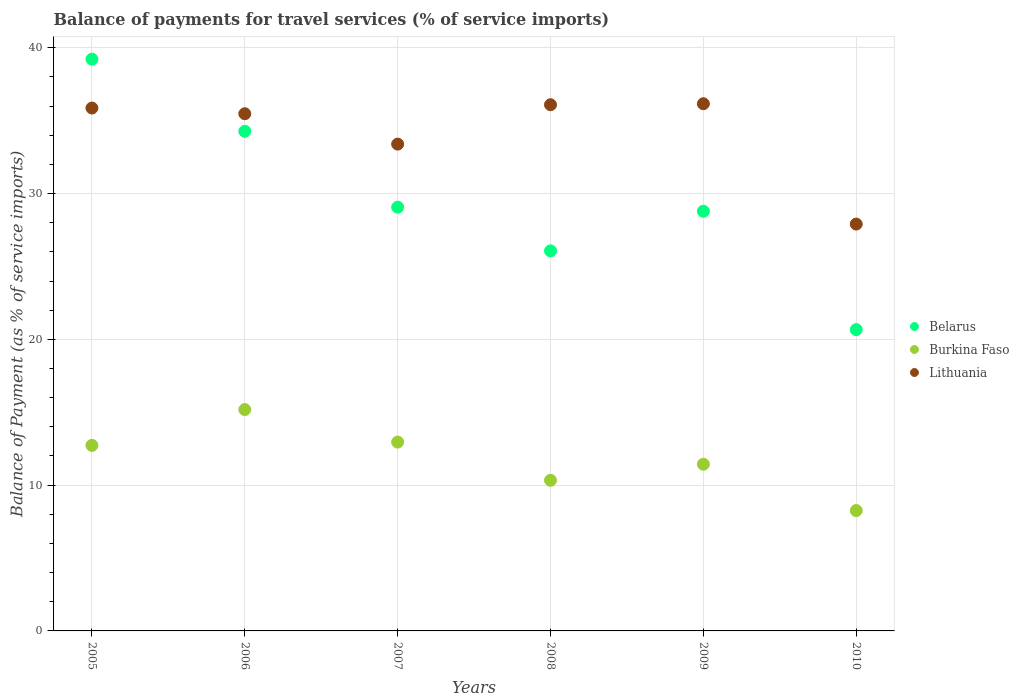How many different coloured dotlines are there?
Provide a succinct answer. 3. What is the balance of payments for travel services in Belarus in 2010?
Offer a very short reply. 20.67. Across all years, what is the maximum balance of payments for travel services in Belarus?
Your answer should be compact. 39.22. Across all years, what is the minimum balance of payments for travel services in Burkina Faso?
Offer a terse response. 8.26. In which year was the balance of payments for travel services in Lithuania minimum?
Offer a very short reply. 2010. What is the total balance of payments for travel services in Belarus in the graph?
Make the answer very short. 178.08. What is the difference between the balance of payments for travel services in Burkina Faso in 2005 and that in 2009?
Give a very brief answer. 1.29. What is the difference between the balance of payments for travel services in Lithuania in 2007 and the balance of payments for travel services in Burkina Faso in 2010?
Your response must be concise. 25.14. What is the average balance of payments for travel services in Burkina Faso per year?
Provide a succinct answer. 11.81. In the year 2008, what is the difference between the balance of payments for travel services in Lithuania and balance of payments for travel services in Burkina Faso?
Give a very brief answer. 25.76. What is the ratio of the balance of payments for travel services in Belarus in 2006 to that in 2010?
Keep it short and to the point. 1.66. What is the difference between the highest and the second highest balance of payments for travel services in Burkina Faso?
Ensure brevity in your answer.  2.23. What is the difference between the highest and the lowest balance of payments for travel services in Lithuania?
Make the answer very short. 8.25. In how many years, is the balance of payments for travel services in Burkina Faso greater than the average balance of payments for travel services in Burkina Faso taken over all years?
Ensure brevity in your answer.  3. Is it the case that in every year, the sum of the balance of payments for travel services in Belarus and balance of payments for travel services in Lithuania  is greater than the balance of payments for travel services in Burkina Faso?
Make the answer very short. Yes. Is the balance of payments for travel services in Belarus strictly greater than the balance of payments for travel services in Burkina Faso over the years?
Your response must be concise. Yes. Are the values on the major ticks of Y-axis written in scientific E-notation?
Your response must be concise. No. Does the graph contain grids?
Provide a short and direct response. Yes. What is the title of the graph?
Provide a short and direct response. Balance of payments for travel services (% of service imports). Does "Cambodia" appear as one of the legend labels in the graph?
Keep it short and to the point. No. What is the label or title of the Y-axis?
Give a very brief answer. Balance of Payment (as % of service imports). What is the Balance of Payment (as % of service imports) in Belarus in 2005?
Provide a short and direct response. 39.22. What is the Balance of Payment (as % of service imports) of Burkina Faso in 2005?
Provide a succinct answer. 12.73. What is the Balance of Payment (as % of service imports) of Lithuania in 2005?
Your answer should be very brief. 35.87. What is the Balance of Payment (as % of service imports) in Belarus in 2006?
Give a very brief answer. 34.27. What is the Balance of Payment (as % of service imports) of Burkina Faso in 2006?
Your answer should be very brief. 15.18. What is the Balance of Payment (as % of service imports) of Lithuania in 2006?
Your answer should be very brief. 35.48. What is the Balance of Payment (as % of service imports) of Belarus in 2007?
Make the answer very short. 29.07. What is the Balance of Payment (as % of service imports) of Burkina Faso in 2007?
Offer a very short reply. 12.95. What is the Balance of Payment (as % of service imports) of Lithuania in 2007?
Give a very brief answer. 33.39. What is the Balance of Payment (as % of service imports) of Belarus in 2008?
Keep it short and to the point. 26.07. What is the Balance of Payment (as % of service imports) in Burkina Faso in 2008?
Provide a short and direct response. 10.33. What is the Balance of Payment (as % of service imports) in Lithuania in 2008?
Offer a very short reply. 36.09. What is the Balance of Payment (as % of service imports) of Belarus in 2009?
Offer a very short reply. 28.79. What is the Balance of Payment (as % of service imports) of Burkina Faso in 2009?
Keep it short and to the point. 11.43. What is the Balance of Payment (as % of service imports) in Lithuania in 2009?
Offer a terse response. 36.16. What is the Balance of Payment (as % of service imports) of Belarus in 2010?
Give a very brief answer. 20.67. What is the Balance of Payment (as % of service imports) of Burkina Faso in 2010?
Offer a terse response. 8.26. What is the Balance of Payment (as % of service imports) in Lithuania in 2010?
Offer a very short reply. 27.91. Across all years, what is the maximum Balance of Payment (as % of service imports) in Belarus?
Ensure brevity in your answer.  39.22. Across all years, what is the maximum Balance of Payment (as % of service imports) in Burkina Faso?
Provide a succinct answer. 15.18. Across all years, what is the maximum Balance of Payment (as % of service imports) of Lithuania?
Your response must be concise. 36.16. Across all years, what is the minimum Balance of Payment (as % of service imports) in Belarus?
Offer a terse response. 20.67. Across all years, what is the minimum Balance of Payment (as % of service imports) in Burkina Faso?
Ensure brevity in your answer.  8.26. Across all years, what is the minimum Balance of Payment (as % of service imports) of Lithuania?
Offer a terse response. 27.91. What is the total Balance of Payment (as % of service imports) of Belarus in the graph?
Keep it short and to the point. 178.08. What is the total Balance of Payment (as % of service imports) of Burkina Faso in the graph?
Give a very brief answer. 70.89. What is the total Balance of Payment (as % of service imports) of Lithuania in the graph?
Offer a very short reply. 204.89. What is the difference between the Balance of Payment (as % of service imports) in Belarus in 2005 and that in 2006?
Ensure brevity in your answer.  4.95. What is the difference between the Balance of Payment (as % of service imports) in Burkina Faso in 2005 and that in 2006?
Your answer should be compact. -2.46. What is the difference between the Balance of Payment (as % of service imports) in Lithuania in 2005 and that in 2006?
Provide a short and direct response. 0.39. What is the difference between the Balance of Payment (as % of service imports) in Belarus in 2005 and that in 2007?
Your answer should be compact. 10.15. What is the difference between the Balance of Payment (as % of service imports) in Burkina Faso in 2005 and that in 2007?
Offer a terse response. -0.23. What is the difference between the Balance of Payment (as % of service imports) of Lithuania in 2005 and that in 2007?
Offer a terse response. 2.47. What is the difference between the Balance of Payment (as % of service imports) of Belarus in 2005 and that in 2008?
Your response must be concise. 13.15. What is the difference between the Balance of Payment (as % of service imports) in Burkina Faso in 2005 and that in 2008?
Your answer should be very brief. 2.39. What is the difference between the Balance of Payment (as % of service imports) in Lithuania in 2005 and that in 2008?
Give a very brief answer. -0.23. What is the difference between the Balance of Payment (as % of service imports) in Belarus in 2005 and that in 2009?
Make the answer very short. 10.43. What is the difference between the Balance of Payment (as % of service imports) in Burkina Faso in 2005 and that in 2009?
Your response must be concise. 1.29. What is the difference between the Balance of Payment (as % of service imports) in Lithuania in 2005 and that in 2009?
Your response must be concise. -0.29. What is the difference between the Balance of Payment (as % of service imports) in Belarus in 2005 and that in 2010?
Offer a terse response. 18.55. What is the difference between the Balance of Payment (as % of service imports) of Burkina Faso in 2005 and that in 2010?
Ensure brevity in your answer.  4.47. What is the difference between the Balance of Payment (as % of service imports) in Lithuania in 2005 and that in 2010?
Your answer should be very brief. 7.96. What is the difference between the Balance of Payment (as % of service imports) of Belarus in 2006 and that in 2007?
Your answer should be very brief. 5.2. What is the difference between the Balance of Payment (as % of service imports) of Burkina Faso in 2006 and that in 2007?
Ensure brevity in your answer.  2.23. What is the difference between the Balance of Payment (as % of service imports) of Lithuania in 2006 and that in 2007?
Your response must be concise. 2.08. What is the difference between the Balance of Payment (as % of service imports) of Belarus in 2006 and that in 2008?
Make the answer very short. 8.2. What is the difference between the Balance of Payment (as % of service imports) in Burkina Faso in 2006 and that in 2008?
Ensure brevity in your answer.  4.85. What is the difference between the Balance of Payment (as % of service imports) of Lithuania in 2006 and that in 2008?
Give a very brief answer. -0.62. What is the difference between the Balance of Payment (as % of service imports) of Belarus in 2006 and that in 2009?
Keep it short and to the point. 5.48. What is the difference between the Balance of Payment (as % of service imports) of Burkina Faso in 2006 and that in 2009?
Offer a terse response. 3.75. What is the difference between the Balance of Payment (as % of service imports) in Lithuania in 2006 and that in 2009?
Give a very brief answer. -0.69. What is the difference between the Balance of Payment (as % of service imports) of Belarus in 2006 and that in 2010?
Keep it short and to the point. 13.6. What is the difference between the Balance of Payment (as % of service imports) in Burkina Faso in 2006 and that in 2010?
Offer a terse response. 6.93. What is the difference between the Balance of Payment (as % of service imports) in Lithuania in 2006 and that in 2010?
Provide a succinct answer. 7.57. What is the difference between the Balance of Payment (as % of service imports) in Belarus in 2007 and that in 2008?
Offer a terse response. 3. What is the difference between the Balance of Payment (as % of service imports) of Burkina Faso in 2007 and that in 2008?
Ensure brevity in your answer.  2.62. What is the difference between the Balance of Payment (as % of service imports) in Lithuania in 2007 and that in 2008?
Your answer should be compact. -2.7. What is the difference between the Balance of Payment (as % of service imports) in Belarus in 2007 and that in 2009?
Your answer should be very brief. 0.28. What is the difference between the Balance of Payment (as % of service imports) in Burkina Faso in 2007 and that in 2009?
Offer a terse response. 1.52. What is the difference between the Balance of Payment (as % of service imports) in Lithuania in 2007 and that in 2009?
Your answer should be very brief. -2.77. What is the difference between the Balance of Payment (as % of service imports) in Belarus in 2007 and that in 2010?
Provide a succinct answer. 8.4. What is the difference between the Balance of Payment (as % of service imports) in Burkina Faso in 2007 and that in 2010?
Offer a very short reply. 4.7. What is the difference between the Balance of Payment (as % of service imports) in Lithuania in 2007 and that in 2010?
Offer a terse response. 5.48. What is the difference between the Balance of Payment (as % of service imports) of Belarus in 2008 and that in 2009?
Give a very brief answer. -2.72. What is the difference between the Balance of Payment (as % of service imports) of Burkina Faso in 2008 and that in 2009?
Offer a very short reply. -1.1. What is the difference between the Balance of Payment (as % of service imports) in Lithuania in 2008 and that in 2009?
Your response must be concise. -0.07. What is the difference between the Balance of Payment (as % of service imports) of Belarus in 2008 and that in 2010?
Your response must be concise. 5.4. What is the difference between the Balance of Payment (as % of service imports) of Burkina Faso in 2008 and that in 2010?
Your answer should be very brief. 2.08. What is the difference between the Balance of Payment (as % of service imports) of Lithuania in 2008 and that in 2010?
Your answer should be compact. 8.19. What is the difference between the Balance of Payment (as % of service imports) of Belarus in 2009 and that in 2010?
Keep it short and to the point. 8.12. What is the difference between the Balance of Payment (as % of service imports) in Burkina Faso in 2009 and that in 2010?
Provide a succinct answer. 3.18. What is the difference between the Balance of Payment (as % of service imports) in Lithuania in 2009 and that in 2010?
Provide a short and direct response. 8.25. What is the difference between the Balance of Payment (as % of service imports) of Belarus in 2005 and the Balance of Payment (as % of service imports) of Burkina Faso in 2006?
Make the answer very short. 24.04. What is the difference between the Balance of Payment (as % of service imports) in Belarus in 2005 and the Balance of Payment (as % of service imports) in Lithuania in 2006?
Provide a succinct answer. 3.74. What is the difference between the Balance of Payment (as % of service imports) of Burkina Faso in 2005 and the Balance of Payment (as % of service imports) of Lithuania in 2006?
Your answer should be very brief. -22.75. What is the difference between the Balance of Payment (as % of service imports) of Belarus in 2005 and the Balance of Payment (as % of service imports) of Burkina Faso in 2007?
Keep it short and to the point. 26.27. What is the difference between the Balance of Payment (as % of service imports) of Belarus in 2005 and the Balance of Payment (as % of service imports) of Lithuania in 2007?
Provide a succinct answer. 5.83. What is the difference between the Balance of Payment (as % of service imports) of Burkina Faso in 2005 and the Balance of Payment (as % of service imports) of Lithuania in 2007?
Provide a succinct answer. -20.67. What is the difference between the Balance of Payment (as % of service imports) in Belarus in 2005 and the Balance of Payment (as % of service imports) in Burkina Faso in 2008?
Give a very brief answer. 28.89. What is the difference between the Balance of Payment (as % of service imports) of Belarus in 2005 and the Balance of Payment (as % of service imports) of Lithuania in 2008?
Ensure brevity in your answer.  3.13. What is the difference between the Balance of Payment (as % of service imports) in Burkina Faso in 2005 and the Balance of Payment (as % of service imports) in Lithuania in 2008?
Your response must be concise. -23.37. What is the difference between the Balance of Payment (as % of service imports) in Belarus in 2005 and the Balance of Payment (as % of service imports) in Burkina Faso in 2009?
Ensure brevity in your answer.  27.79. What is the difference between the Balance of Payment (as % of service imports) of Belarus in 2005 and the Balance of Payment (as % of service imports) of Lithuania in 2009?
Make the answer very short. 3.06. What is the difference between the Balance of Payment (as % of service imports) in Burkina Faso in 2005 and the Balance of Payment (as % of service imports) in Lithuania in 2009?
Your response must be concise. -23.44. What is the difference between the Balance of Payment (as % of service imports) in Belarus in 2005 and the Balance of Payment (as % of service imports) in Burkina Faso in 2010?
Provide a short and direct response. 30.96. What is the difference between the Balance of Payment (as % of service imports) in Belarus in 2005 and the Balance of Payment (as % of service imports) in Lithuania in 2010?
Ensure brevity in your answer.  11.31. What is the difference between the Balance of Payment (as % of service imports) in Burkina Faso in 2005 and the Balance of Payment (as % of service imports) in Lithuania in 2010?
Keep it short and to the point. -15.18. What is the difference between the Balance of Payment (as % of service imports) in Belarus in 2006 and the Balance of Payment (as % of service imports) in Burkina Faso in 2007?
Your answer should be very brief. 21.32. What is the difference between the Balance of Payment (as % of service imports) of Belarus in 2006 and the Balance of Payment (as % of service imports) of Lithuania in 2007?
Keep it short and to the point. 0.88. What is the difference between the Balance of Payment (as % of service imports) of Burkina Faso in 2006 and the Balance of Payment (as % of service imports) of Lithuania in 2007?
Your answer should be very brief. -18.21. What is the difference between the Balance of Payment (as % of service imports) of Belarus in 2006 and the Balance of Payment (as % of service imports) of Burkina Faso in 2008?
Ensure brevity in your answer.  23.94. What is the difference between the Balance of Payment (as % of service imports) in Belarus in 2006 and the Balance of Payment (as % of service imports) in Lithuania in 2008?
Make the answer very short. -1.82. What is the difference between the Balance of Payment (as % of service imports) of Burkina Faso in 2006 and the Balance of Payment (as % of service imports) of Lithuania in 2008?
Your response must be concise. -20.91. What is the difference between the Balance of Payment (as % of service imports) in Belarus in 2006 and the Balance of Payment (as % of service imports) in Burkina Faso in 2009?
Your answer should be compact. 22.84. What is the difference between the Balance of Payment (as % of service imports) of Belarus in 2006 and the Balance of Payment (as % of service imports) of Lithuania in 2009?
Your response must be concise. -1.89. What is the difference between the Balance of Payment (as % of service imports) of Burkina Faso in 2006 and the Balance of Payment (as % of service imports) of Lithuania in 2009?
Your answer should be very brief. -20.98. What is the difference between the Balance of Payment (as % of service imports) of Belarus in 2006 and the Balance of Payment (as % of service imports) of Burkina Faso in 2010?
Give a very brief answer. 26.01. What is the difference between the Balance of Payment (as % of service imports) in Belarus in 2006 and the Balance of Payment (as % of service imports) in Lithuania in 2010?
Give a very brief answer. 6.36. What is the difference between the Balance of Payment (as % of service imports) in Burkina Faso in 2006 and the Balance of Payment (as % of service imports) in Lithuania in 2010?
Provide a succinct answer. -12.72. What is the difference between the Balance of Payment (as % of service imports) in Belarus in 2007 and the Balance of Payment (as % of service imports) in Burkina Faso in 2008?
Your answer should be compact. 18.73. What is the difference between the Balance of Payment (as % of service imports) of Belarus in 2007 and the Balance of Payment (as % of service imports) of Lithuania in 2008?
Offer a terse response. -7.03. What is the difference between the Balance of Payment (as % of service imports) of Burkina Faso in 2007 and the Balance of Payment (as % of service imports) of Lithuania in 2008?
Provide a succinct answer. -23.14. What is the difference between the Balance of Payment (as % of service imports) of Belarus in 2007 and the Balance of Payment (as % of service imports) of Burkina Faso in 2009?
Keep it short and to the point. 17.63. What is the difference between the Balance of Payment (as % of service imports) in Belarus in 2007 and the Balance of Payment (as % of service imports) in Lithuania in 2009?
Keep it short and to the point. -7.09. What is the difference between the Balance of Payment (as % of service imports) of Burkina Faso in 2007 and the Balance of Payment (as % of service imports) of Lithuania in 2009?
Offer a very short reply. -23.21. What is the difference between the Balance of Payment (as % of service imports) of Belarus in 2007 and the Balance of Payment (as % of service imports) of Burkina Faso in 2010?
Provide a succinct answer. 20.81. What is the difference between the Balance of Payment (as % of service imports) in Belarus in 2007 and the Balance of Payment (as % of service imports) in Lithuania in 2010?
Your answer should be compact. 1.16. What is the difference between the Balance of Payment (as % of service imports) of Burkina Faso in 2007 and the Balance of Payment (as % of service imports) of Lithuania in 2010?
Your answer should be very brief. -14.95. What is the difference between the Balance of Payment (as % of service imports) in Belarus in 2008 and the Balance of Payment (as % of service imports) in Burkina Faso in 2009?
Provide a short and direct response. 14.64. What is the difference between the Balance of Payment (as % of service imports) in Belarus in 2008 and the Balance of Payment (as % of service imports) in Lithuania in 2009?
Your answer should be compact. -10.09. What is the difference between the Balance of Payment (as % of service imports) in Burkina Faso in 2008 and the Balance of Payment (as % of service imports) in Lithuania in 2009?
Your response must be concise. -25.83. What is the difference between the Balance of Payment (as % of service imports) of Belarus in 2008 and the Balance of Payment (as % of service imports) of Burkina Faso in 2010?
Provide a succinct answer. 17.81. What is the difference between the Balance of Payment (as % of service imports) of Belarus in 2008 and the Balance of Payment (as % of service imports) of Lithuania in 2010?
Give a very brief answer. -1.84. What is the difference between the Balance of Payment (as % of service imports) in Burkina Faso in 2008 and the Balance of Payment (as % of service imports) in Lithuania in 2010?
Make the answer very short. -17.57. What is the difference between the Balance of Payment (as % of service imports) of Belarus in 2009 and the Balance of Payment (as % of service imports) of Burkina Faso in 2010?
Your answer should be very brief. 20.53. What is the difference between the Balance of Payment (as % of service imports) in Belarus in 2009 and the Balance of Payment (as % of service imports) in Lithuania in 2010?
Ensure brevity in your answer.  0.88. What is the difference between the Balance of Payment (as % of service imports) in Burkina Faso in 2009 and the Balance of Payment (as % of service imports) in Lithuania in 2010?
Provide a short and direct response. -16.47. What is the average Balance of Payment (as % of service imports) of Belarus per year?
Make the answer very short. 29.68. What is the average Balance of Payment (as % of service imports) of Burkina Faso per year?
Offer a very short reply. 11.81. What is the average Balance of Payment (as % of service imports) of Lithuania per year?
Make the answer very short. 34.15. In the year 2005, what is the difference between the Balance of Payment (as % of service imports) in Belarus and Balance of Payment (as % of service imports) in Burkina Faso?
Provide a short and direct response. 26.49. In the year 2005, what is the difference between the Balance of Payment (as % of service imports) in Belarus and Balance of Payment (as % of service imports) in Lithuania?
Offer a terse response. 3.35. In the year 2005, what is the difference between the Balance of Payment (as % of service imports) in Burkina Faso and Balance of Payment (as % of service imports) in Lithuania?
Keep it short and to the point. -23.14. In the year 2006, what is the difference between the Balance of Payment (as % of service imports) in Belarus and Balance of Payment (as % of service imports) in Burkina Faso?
Offer a terse response. 19.09. In the year 2006, what is the difference between the Balance of Payment (as % of service imports) of Belarus and Balance of Payment (as % of service imports) of Lithuania?
Make the answer very short. -1.21. In the year 2006, what is the difference between the Balance of Payment (as % of service imports) in Burkina Faso and Balance of Payment (as % of service imports) in Lithuania?
Give a very brief answer. -20.29. In the year 2007, what is the difference between the Balance of Payment (as % of service imports) of Belarus and Balance of Payment (as % of service imports) of Burkina Faso?
Offer a very short reply. 16.11. In the year 2007, what is the difference between the Balance of Payment (as % of service imports) in Belarus and Balance of Payment (as % of service imports) in Lithuania?
Offer a very short reply. -4.32. In the year 2007, what is the difference between the Balance of Payment (as % of service imports) in Burkina Faso and Balance of Payment (as % of service imports) in Lithuania?
Your answer should be very brief. -20.44. In the year 2008, what is the difference between the Balance of Payment (as % of service imports) of Belarus and Balance of Payment (as % of service imports) of Burkina Faso?
Provide a succinct answer. 15.74. In the year 2008, what is the difference between the Balance of Payment (as % of service imports) of Belarus and Balance of Payment (as % of service imports) of Lithuania?
Ensure brevity in your answer.  -10.02. In the year 2008, what is the difference between the Balance of Payment (as % of service imports) of Burkina Faso and Balance of Payment (as % of service imports) of Lithuania?
Offer a very short reply. -25.76. In the year 2009, what is the difference between the Balance of Payment (as % of service imports) of Belarus and Balance of Payment (as % of service imports) of Burkina Faso?
Give a very brief answer. 17.35. In the year 2009, what is the difference between the Balance of Payment (as % of service imports) of Belarus and Balance of Payment (as % of service imports) of Lithuania?
Offer a terse response. -7.37. In the year 2009, what is the difference between the Balance of Payment (as % of service imports) in Burkina Faso and Balance of Payment (as % of service imports) in Lithuania?
Your answer should be compact. -24.73. In the year 2010, what is the difference between the Balance of Payment (as % of service imports) of Belarus and Balance of Payment (as % of service imports) of Burkina Faso?
Keep it short and to the point. 12.41. In the year 2010, what is the difference between the Balance of Payment (as % of service imports) in Belarus and Balance of Payment (as % of service imports) in Lithuania?
Give a very brief answer. -7.24. In the year 2010, what is the difference between the Balance of Payment (as % of service imports) in Burkina Faso and Balance of Payment (as % of service imports) in Lithuania?
Ensure brevity in your answer.  -19.65. What is the ratio of the Balance of Payment (as % of service imports) of Belarus in 2005 to that in 2006?
Make the answer very short. 1.14. What is the ratio of the Balance of Payment (as % of service imports) in Burkina Faso in 2005 to that in 2006?
Your answer should be compact. 0.84. What is the ratio of the Balance of Payment (as % of service imports) in Belarus in 2005 to that in 2007?
Your answer should be very brief. 1.35. What is the ratio of the Balance of Payment (as % of service imports) in Burkina Faso in 2005 to that in 2007?
Your answer should be compact. 0.98. What is the ratio of the Balance of Payment (as % of service imports) of Lithuania in 2005 to that in 2007?
Ensure brevity in your answer.  1.07. What is the ratio of the Balance of Payment (as % of service imports) in Belarus in 2005 to that in 2008?
Keep it short and to the point. 1.5. What is the ratio of the Balance of Payment (as % of service imports) in Burkina Faso in 2005 to that in 2008?
Your answer should be very brief. 1.23. What is the ratio of the Balance of Payment (as % of service imports) of Belarus in 2005 to that in 2009?
Your answer should be compact. 1.36. What is the ratio of the Balance of Payment (as % of service imports) of Burkina Faso in 2005 to that in 2009?
Make the answer very short. 1.11. What is the ratio of the Balance of Payment (as % of service imports) in Belarus in 2005 to that in 2010?
Offer a very short reply. 1.9. What is the ratio of the Balance of Payment (as % of service imports) of Burkina Faso in 2005 to that in 2010?
Give a very brief answer. 1.54. What is the ratio of the Balance of Payment (as % of service imports) of Lithuania in 2005 to that in 2010?
Keep it short and to the point. 1.29. What is the ratio of the Balance of Payment (as % of service imports) in Belarus in 2006 to that in 2007?
Your answer should be compact. 1.18. What is the ratio of the Balance of Payment (as % of service imports) in Burkina Faso in 2006 to that in 2007?
Your answer should be very brief. 1.17. What is the ratio of the Balance of Payment (as % of service imports) of Lithuania in 2006 to that in 2007?
Provide a succinct answer. 1.06. What is the ratio of the Balance of Payment (as % of service imports) in Belarus in 2006 to that in 2008?
Your answer should be compact. 1.31. What is the ratio of the Balance of Payment (as % of service imports) in Burkina Faso in 2006 to that in 2008?
Make the answer very short. 1.47. What is the ratio of the Balance of Payment (as % of service imports) of Lithuania in 2006 to that in 2008?
Your answer should be very brief. 0.98. What is the ratio of the Balance of Payment (as % of service imports) in Belarus in 2006 to that in 2009?
Provide a short and direct response. 1.19. What is the ratio of the Balance of Payment (as % of service imports) of Burkina Faso in 2006 to that in 2009?
Your answer should be very brief. 1.33. What is the ratio of the Balance of Payment (as % of service imports) in Lithuania in 2006 to that in 2009?
Your answer should be very brief. 0.98. What is the ratio of the Balance of Payment (as % of service imports) in Belarus in 2006 to that in 2010?
Your response must be concise. 1.66. What is the ratio of the Balance of Payment (as % of service imports) in Burkina Faso in 2006 to that in 2010?
Your answer should be very brief. 1.84. What is the ratio of the Balance of Payment (as % of service imports) in Lithuania in 2006 to that in 2010?
Give a very brief answer. 1.27. What is the ratio of the Balance of Payment (as % of service imports) of Belarus in 2007 to that in 2008?
Give a very brief answer. 1.11. What is the ratio of the Balance of Payment (as % of service imports) of Burkina Faso in 2007 to that in 2008?
Offer a very short reply. 1.25. What is the ratio of the Balance of Payment (as % of service imports) of Lithuania in 2007 to that in 2008?
Keep it short and to the point. 0.93. What is the ratio of the Balance of Payment (as % of service imports) of Belarus in 2007 to that in 2009?
Make the answer very short. 1.01. What is the ratio of the Balance of Payment (as % of service imports) in Burkina Faso in 2007 to that in 2009?
Give a very brief answer. 1.13. What is the ratio of the Balance of Payment (as % of service imports) of Lithuania in 2007 to that in 2009?
Provide a short and direct response. 0.92. What is the ratio of the Balance of Payment (as % of service imports) of Belarus in 2007 to that in 2010?
Give a very brief answer. 1.41. What is the ratio of the Balance of Payment (as % of service imports) of Burkina Faso in 2007 to that in 2010?
Give a very brief answer. 1.57. What is the ratio of the Balance of Payment (as % of service imports) in Lithuania in 2007 to that in 2010?
Offer a very short reply. 1.2. What is the ratio of the Balance of Payment (as % of service imports) of Belarus in 2008 to that in 2009?
Your answer should be very brief. 0.91. What is the ratio of the Balance of Payment (as % of service imports) of Burkina Faso in 2008 to that in 2009?
Provide a succinct answer. 0.9. What is the ratio of the Balance of Payment (as % of service imports) of Lithuania in 2008 to that in 2009?
Offer a terse response. 1. What is the ratio of the Balance of Payment (as % of service imports) of Belarus in 2008 to that in 2010?
Ensure brevity in your answer.  1.26. What is the ratio of the Balance of Payment (as % of service imports) in Burkina Faso in 2008 to that in 2010?
Your answer should be very brief. 1.25. What is the ratio of the Balance of Payment (as % of service imports) of Lithuania in 2008 to that in 2010?
Keep it short and to the point. 1.29. What is the ratio of the Balance of Payment (as % of service imports) of Belarus in 2009 to that in 2010?
Ensure brevity in your answer.  1.39. What is the ratio of the Balance of Payment (as % of service imports) of Burkina Faso in 2009 to that in 2010?
Make the answer very short. 1.38. What is the ratio of the Balance of Payment (as % of service imports) in Lithuania in 2009 to that in 2010?
Provide a short and direct response. 1.3. What is the difference between the highest and the second highest Balance of Payment (as % of service imports) of Belarus?
Keep it short and to the point. 4.95. What is the difference between the highest and the second highest Balance of Payment (as % of service imports) in Burkina Faso?
Provide a short and direct response. 2.23. What is the difference between the highest and the second highest Balance of Payment (as % of service imports) in Lithuania?
Provide a short and direct response. 0.07. What is the difference between the highest and the lowest Balance of Payment (as % of service imports) in Belarus?
Give a very brief answer. 18.55. What is the difference between the highest and the lowest Balance of Payment (as % of service imports) in Burkina Faso?
Keep it short and to the point. 6.93. What is the difference between the highest and the lowest Balance of Payment (as % of service imports) in Lithuania?
Provide a succinct answer. 8.25. 